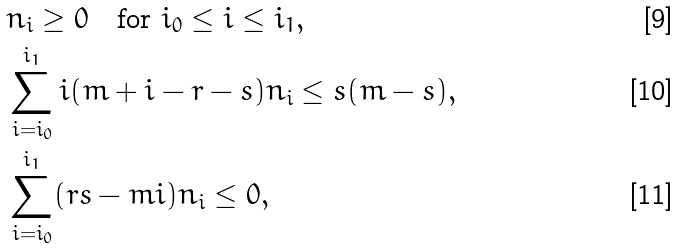<formula> <loc_0><loc_0><loc_500><loc_500>& n _ { i } \geq 0 \quad \text {for $i_{0}\leq i\leq i_{1}$} , \\ & \sum _ { i = i _ { 0 } } ^ { i _ { 1 } } i ( m + i - r - s ) n _ { i } \leq s ( m - s ) , \\ & \sum _ { i = i _ { 0 } } ^ { i _ { 1 } } ( r s - m i ) n _ { i } \leq 0 ,</formula> 